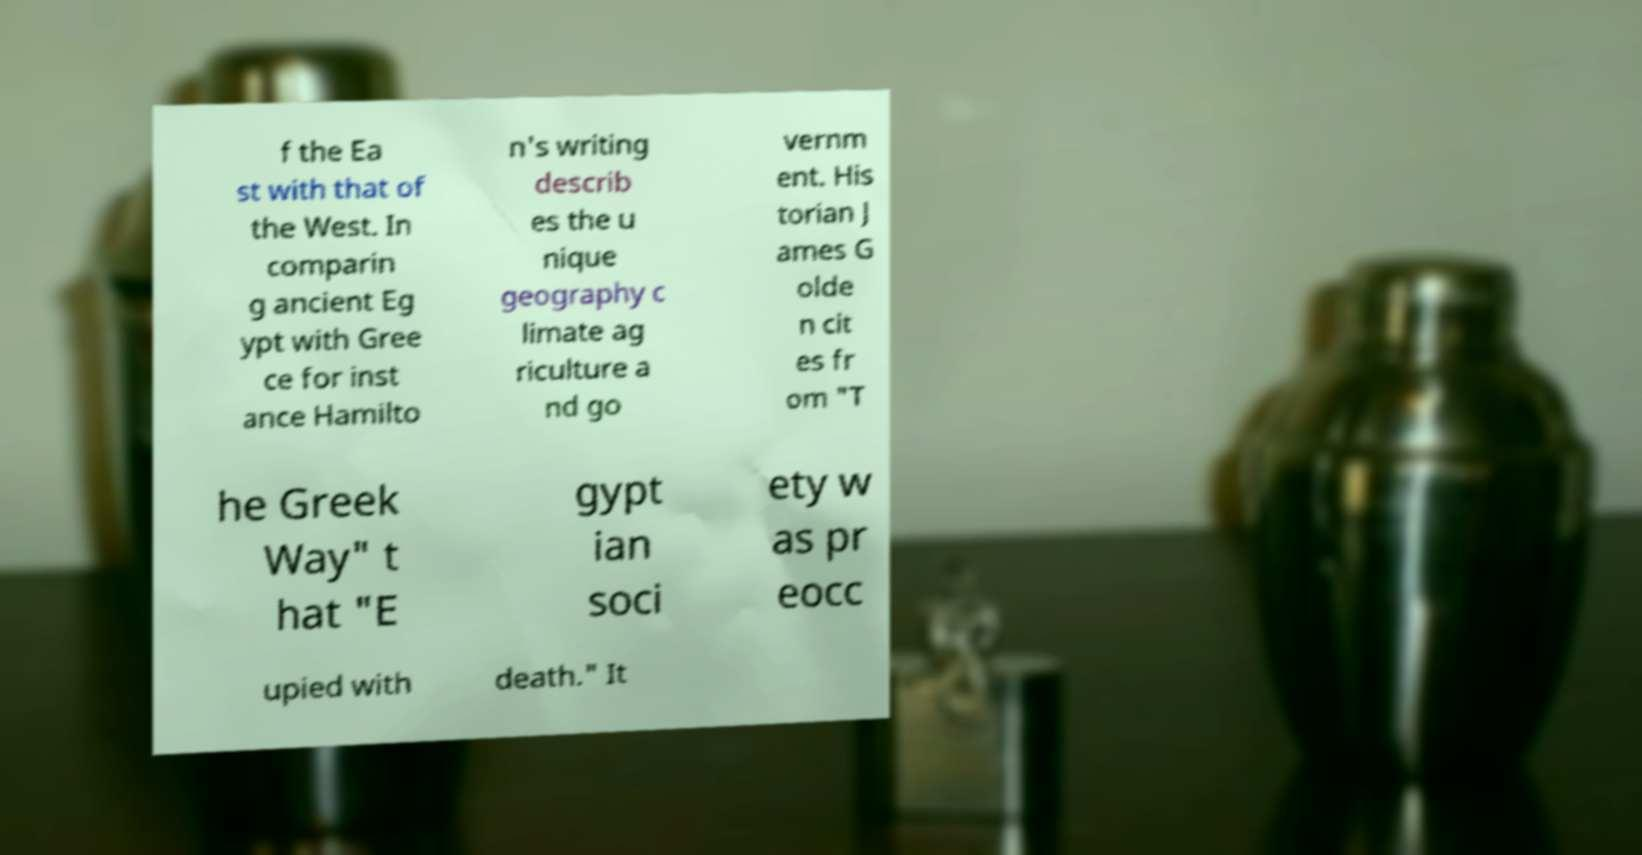Could you extract and type out the text from this image? f the Ea st with that of the West. In comparin g ancient Eg ypt with Gree ce for inst ance Hamilto n's writing describ es the u nique geography c limate ag riculture a nd go vernm ent. His torian J ames G olde n cit es fr om "T he Greek Way" t hat "E gypt ian soci ety w as pr eocc upied with death." It 